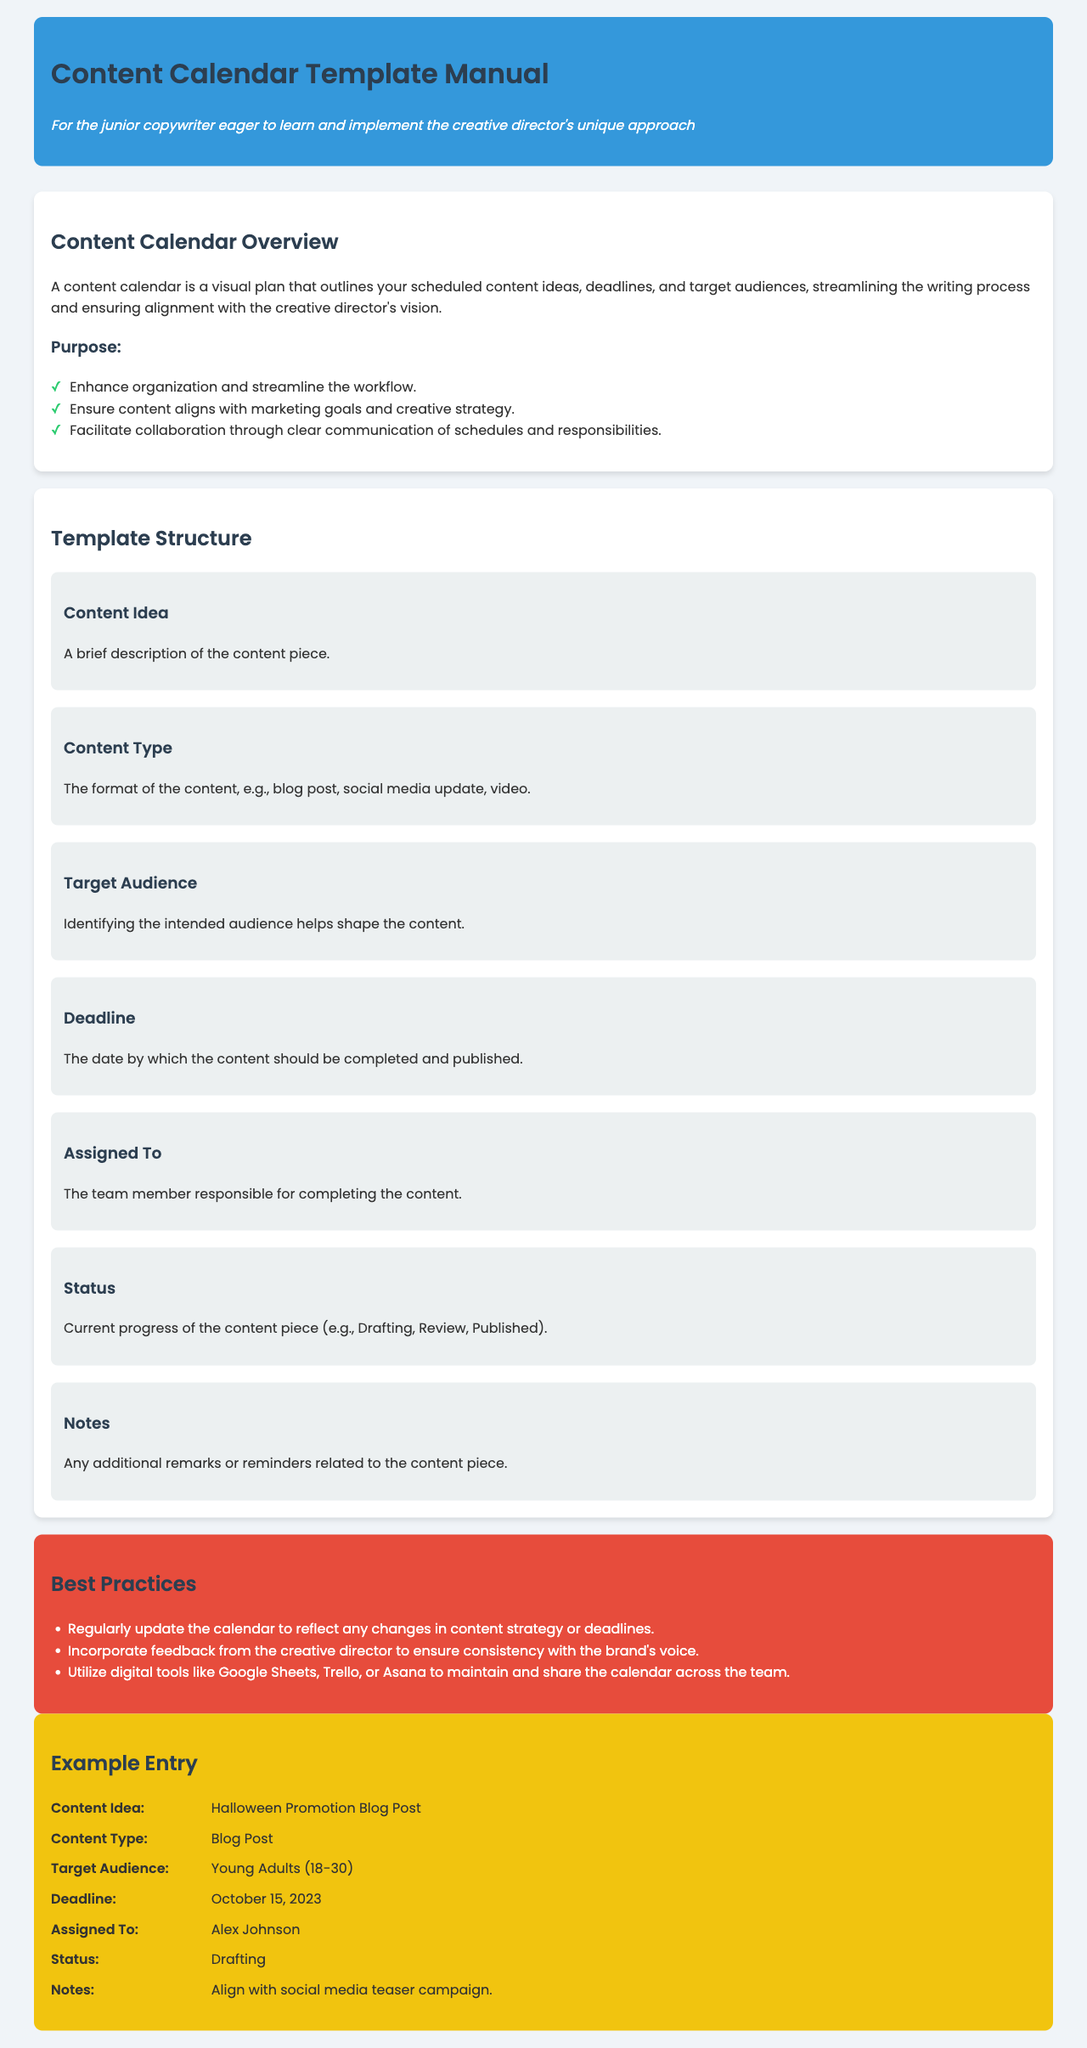What is the main purpose of a content calendar? The main purpose of a content calendar is to streamline the writing process and ensure alignment with the creative director's vision.
Answer: Streamline the writing process and ensure alignment with the creative director's vision How many items are in the template structure? The template structure includes categories such as Content Idea, Content Type, Target Audience, Deadline, Assigned To, Status, and Notes, totaling seven items.
Answer: Seven items Who is responsible for the content piece in the example entry? The example entry lists Alex Johnson as the person responsible for the content piece.
Answer: Alex Johnson What is the deadline for the Halloween Promotion Blog Post? The example entry specifies October 15, 2023, as the deadline for the content piece.
Answer: October 15, 2023 What content type is associated with the Halloween Promotion Blog Post? The example identifies the content type of the Halloween Promotion as a Blog Post.
Answer: Blog Post What should be incorporated into the content calendar to ensure brand consistency? Incorporating feedback from the creative director is essential for maintaining consistency with the brand's voice.
Answer: Feedback from the creative director What color represents the best practices section in the document? The best practices section has a red background color, making it distinct.
Answer: Red What is the target audience for the content piece in the example? The example specifies that the target audience for the Halloween Promotion Blog Post is Young Adults (18-30).
Answer: Young Adults (18-30) 